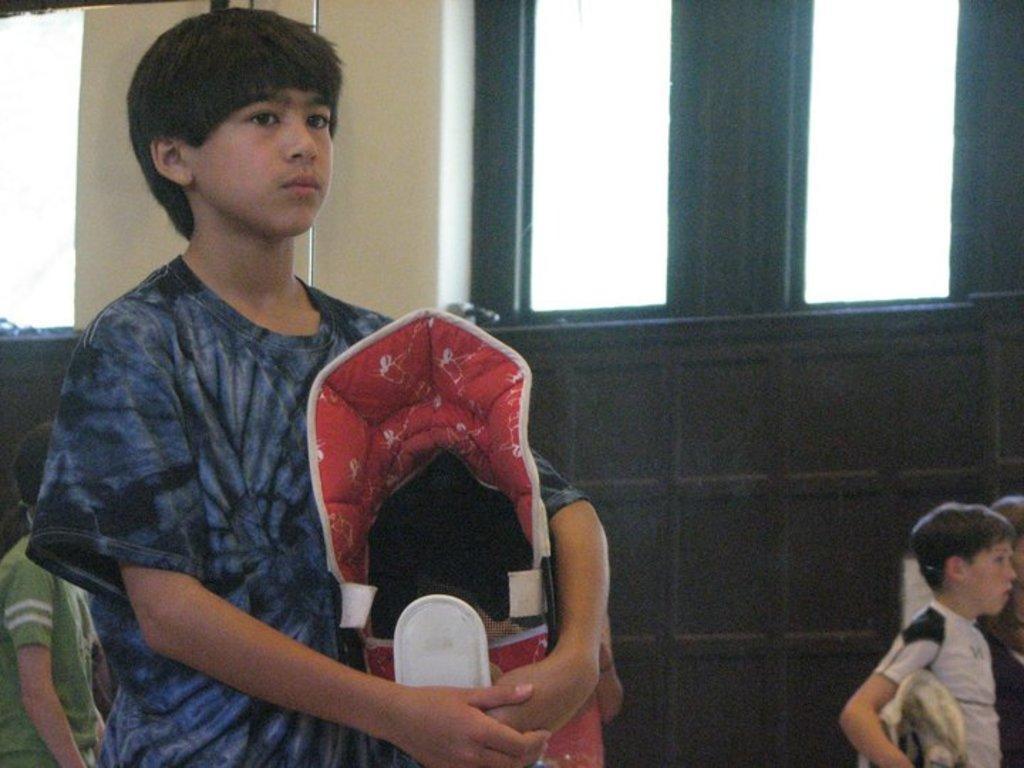Could you give a brief overview of what you see in this image? In the picture we can see a boy standing and holding something in the hand and he is wearing a blue T-shirt and behind him we can see a wall with a window and some other boys standing near it holding something in the hand. 